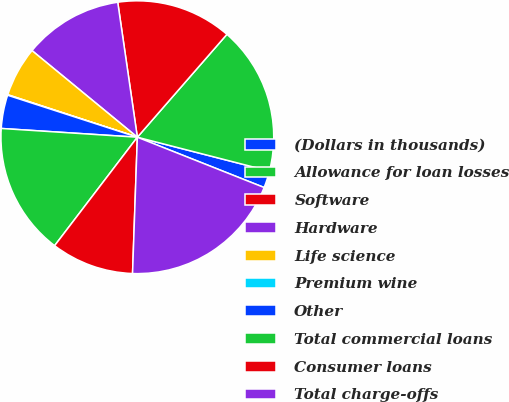Convert chart to OTSL. <chart><loc_0><loc_0><loc_500><loc_500><pie_chart><fcel>(Dollars in thousands)<fcel>Allowance for loan losses<fcel>Software<fcel>Hardware<fcel>Life science<fcel>Premium wine<fcel>Other<fcel>Total commercial loans<fcel>Consumer loans<fcel>Total charge-offs<nl><fcel>2.01%<fcel>17.6%<fcel>13.7%<fcel>11.75%<fcel>5.91%<fcel>0.06%<fcel>3.96%<fcel>15.65%<fcel>9.81%<fcel>19.55%<nl></chart> 